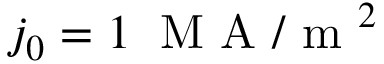<formula> <loc_0><loc_0><loc_500><loc_500>j _ { 0 } = 1 \, M A / m ^ { 2 }</formula> 